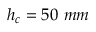Convert formula to latex. <formula><loc_0><loc_0><loc_500><loc_500>h _ { c } = 5 0 m m</formula> 